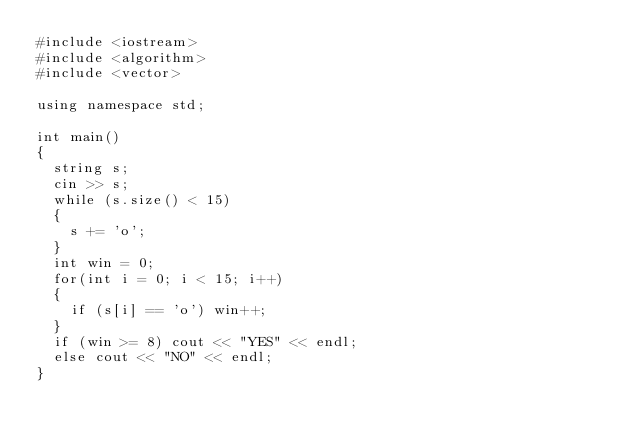<code> <loc_0><loc_0><loc_500><loc_500><_C++_>#include <iostream>
#include <algorithm>
#include <vector>

using namespace std;

int main()
{
	string s;
	cin >> s;
	while (s.size() < 15)
	{
		s += 'o';
	}
	int win = 0;
	for(int i = 0; i < 15; i++)
	{
		if (s[i] == 'o') win++;
	}
	if (win >= 8) cout << "YES" << endl;
	else cout << "NO" << endl;
}</code> 